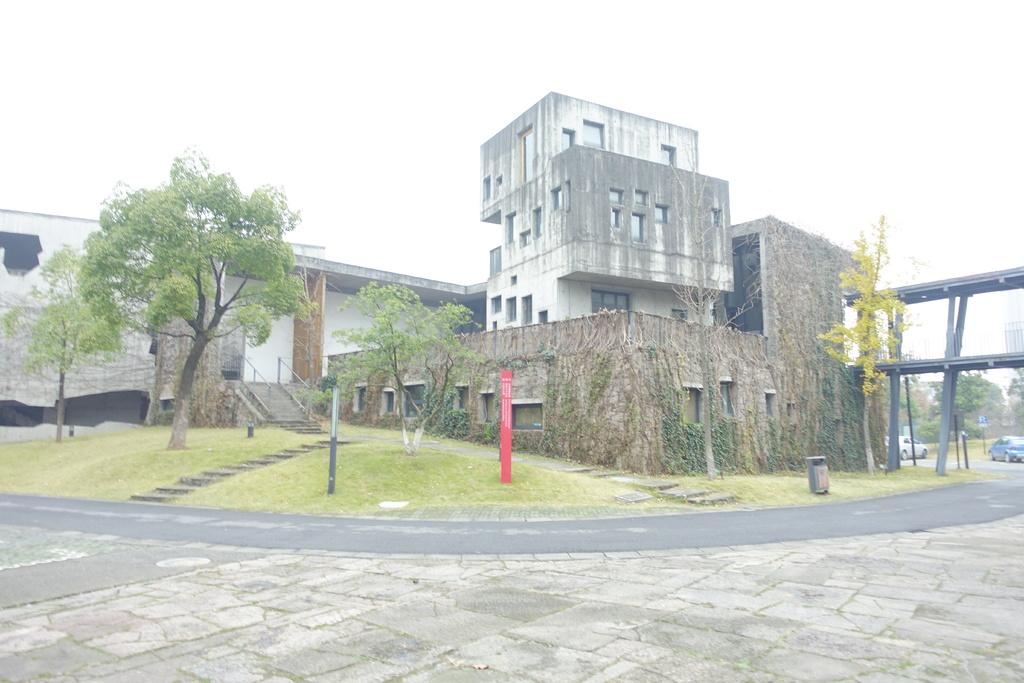What is the main feature of the image? There is a road in the image. What can be seen on the other side of the road? There is a building and trees on the other side of the road. What type of cabbage is being harvested in the image? There is no cabbage present in the image; it features a road, a building, and trees. 